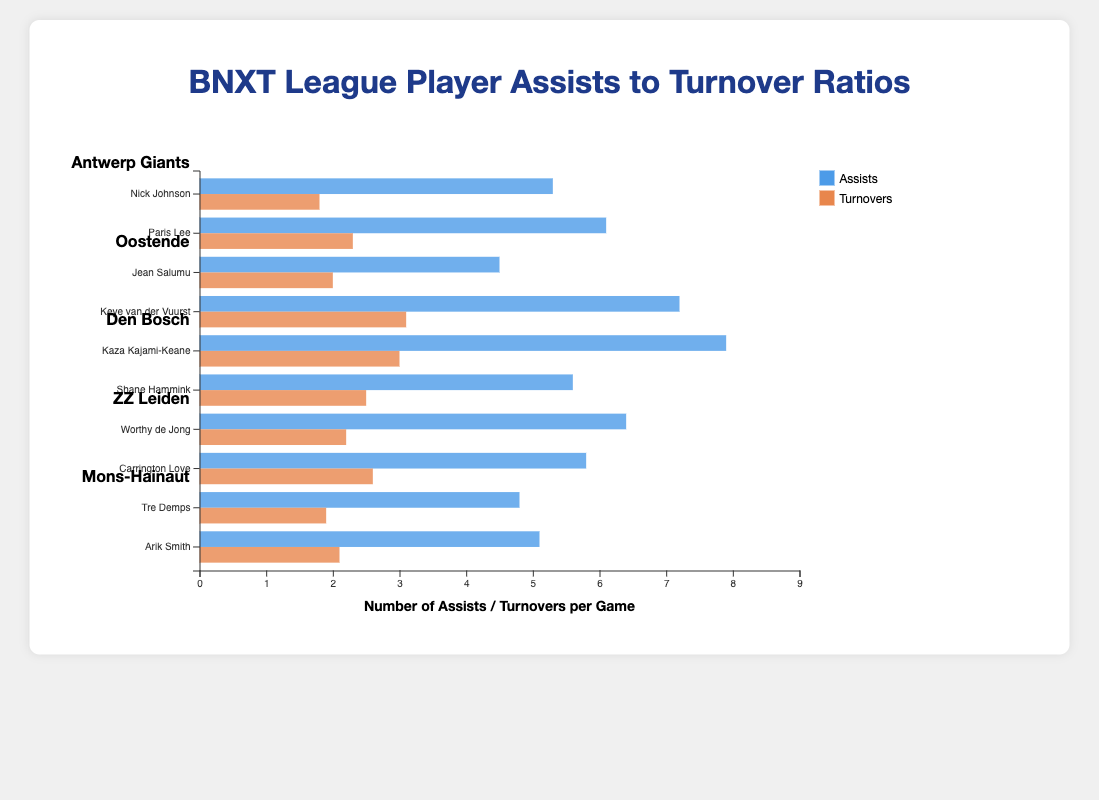Which player has the highest number of assists per game? Looking at the bars for assists, Kaza Kajami-Keane from Den Bosch has an assist bar that extends the furthest to the right.
Answer: Kaza Kajami-Keane Who has a lower turnover rate, Paris Lee or Jean Salumu? Comparing the turnover bars for Paris Lee and Jean Salumu, Jean Salumu's bar is shorter in length.
Answer: Jean Salumu What is the difference in assists between Kaza Kajami-Keane and Keye van der Vuurst? Kaza Kajami-Keane has 7.9 assists, and Keye van der Vuurst has 7.2 assists. The difference is calculated by 7.9 - 7.2.
Answer: 0.7 Which team has the best average assists to turnovers ratio? To find the average assists to turnovers ratio for each team: 1) Calculate the ratio for each player, 2) Find the average for all players in the team.
   - Antwerp Giants: (5.3/1.8 + 6.1/2.3)/2 = 2.94
   - Oostende: (4.5/2.0 + 7.2/3.1)/2 = 2.33
   - Den Bosch: (7.9/3.0 + 5.6/2.5)/2 = 2.28
   - ZZ Leiden: (6.4/2.2 + 5.8/2.6)/2 = 2.53
   - Mons-Hainaut: (4.8/1.9 + 5.1/2.1)/2 = 2.41
   The Antwerp Giants have the highest average ratio.
Answer: Antwerp Giants Who has a higher assists to turnovers ratio, Nick Johnson or Tre Demps? Calculate the ratio for each: 
   - Nick Johnson: 5.3/1.8 = 2.94
   - Tre Demps: 4.8/1.9 = 2.53
   Nick Johnson has a higher ratio.
Answer: Nick Johnson Who has more turnovers, Worthy de Jong or Arik Smith? Comparing the turnover bars for Worthy de Jong (2.2) and Arik Smith (2.1), Worthy de Jong's bar is slightly longer.
Answer: Worthy de Jong What's the average number of assists for players on ZZ Leiden? ZZ Leiden players, Worthy de Jong and Carrington Love, have 6.4 and 5.8 assists respectively. The average is calculated as (6.4 + 5.8)/2.
Answer: 6.1 Which player has the lowest number of turnovers? The turnover bars for each player show that Nick Johnson has the shortest turnover bar at 1.8 turnovers per game.
Answer: Nick Johnson What is the total number of assists for players in the Antwerp Giants? Nick Johnson (5.3) and Paris Lee (6.1) are the players from Antwerp Giants. The total assists are 5.3 + 6.1.
Answer: 11.4 